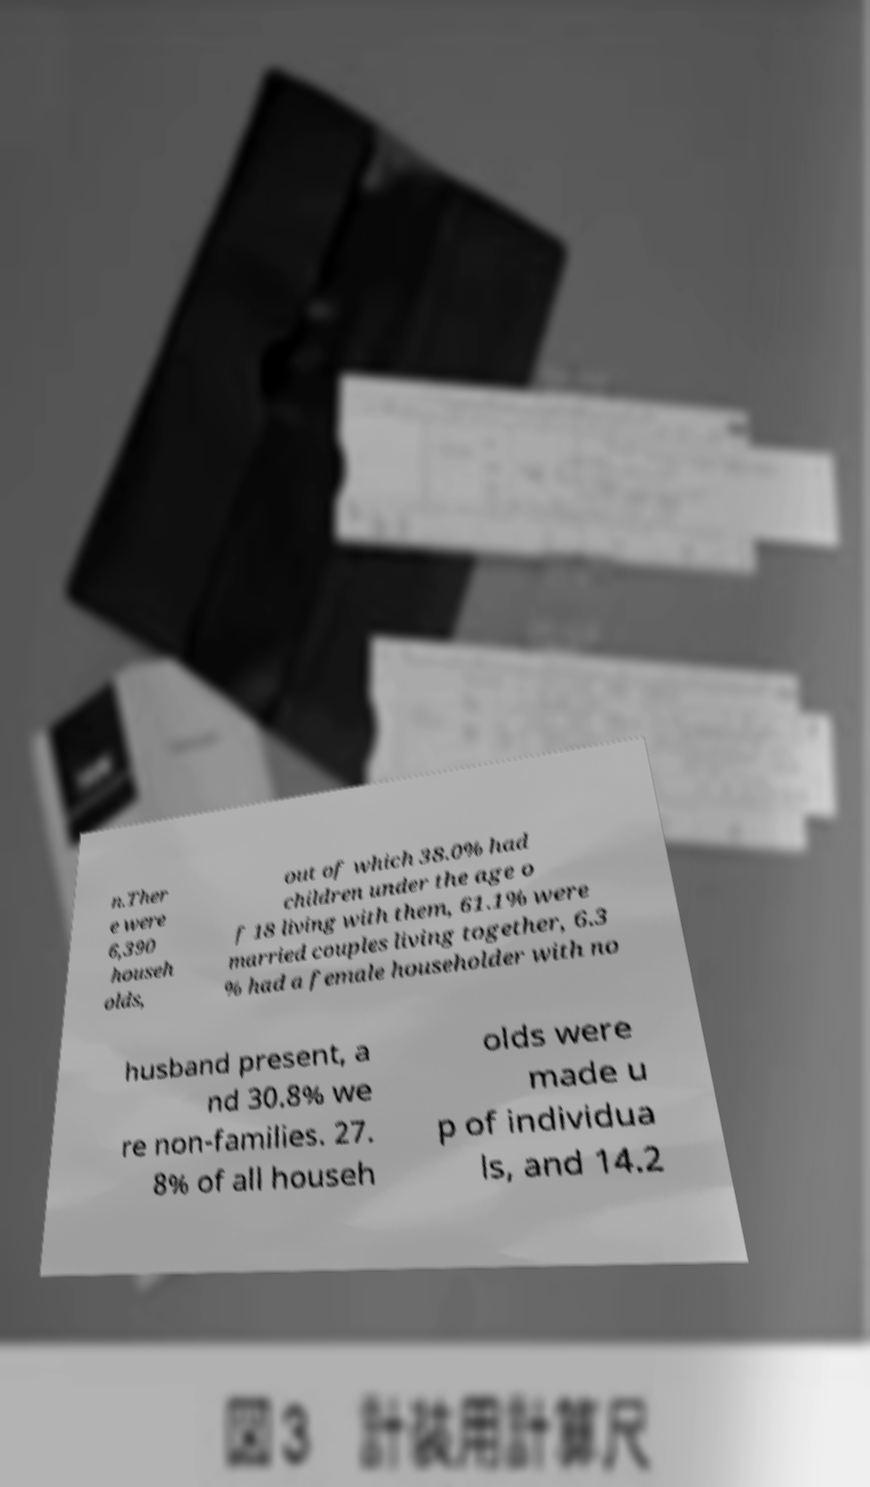Please identify and transcribe the text found in this image. n.Ther e were 6,390 househ olds, out of which 38.0% had children under the age o f 18 living with them, 61.1% were married couples living together, 6.3 % had a female householder with no husband present, a nd 30.8% we re non-families. 27. 8% of all househ olds were made u p of individua ls, and 14.2 